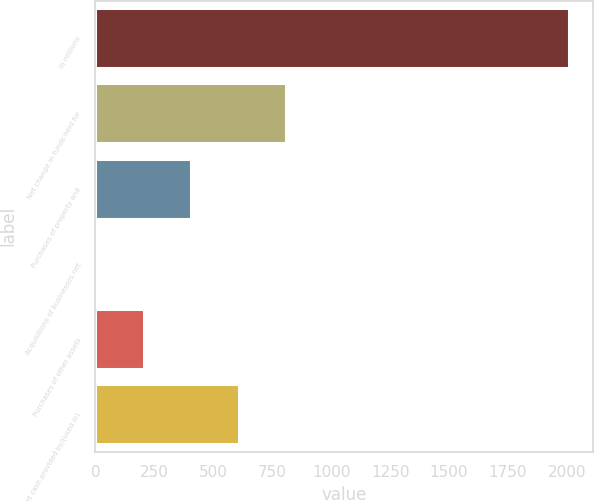Convert chart. <chart><loc_0><loc_0><loc_500><loc_500><bar_chart><fcel>In millions<fcel>Net change in funds held for<fcel>Purchases of property and<fcel>Acquisitions of businesses net<fcel>Purchases of other assets<fcel>Net cash provided by/(used in)<nl><fcel>2009<fcel>807.44<fcel>406.92<fcel>6.4<fcel>206.66<fcel>607.18<nl></chart> 